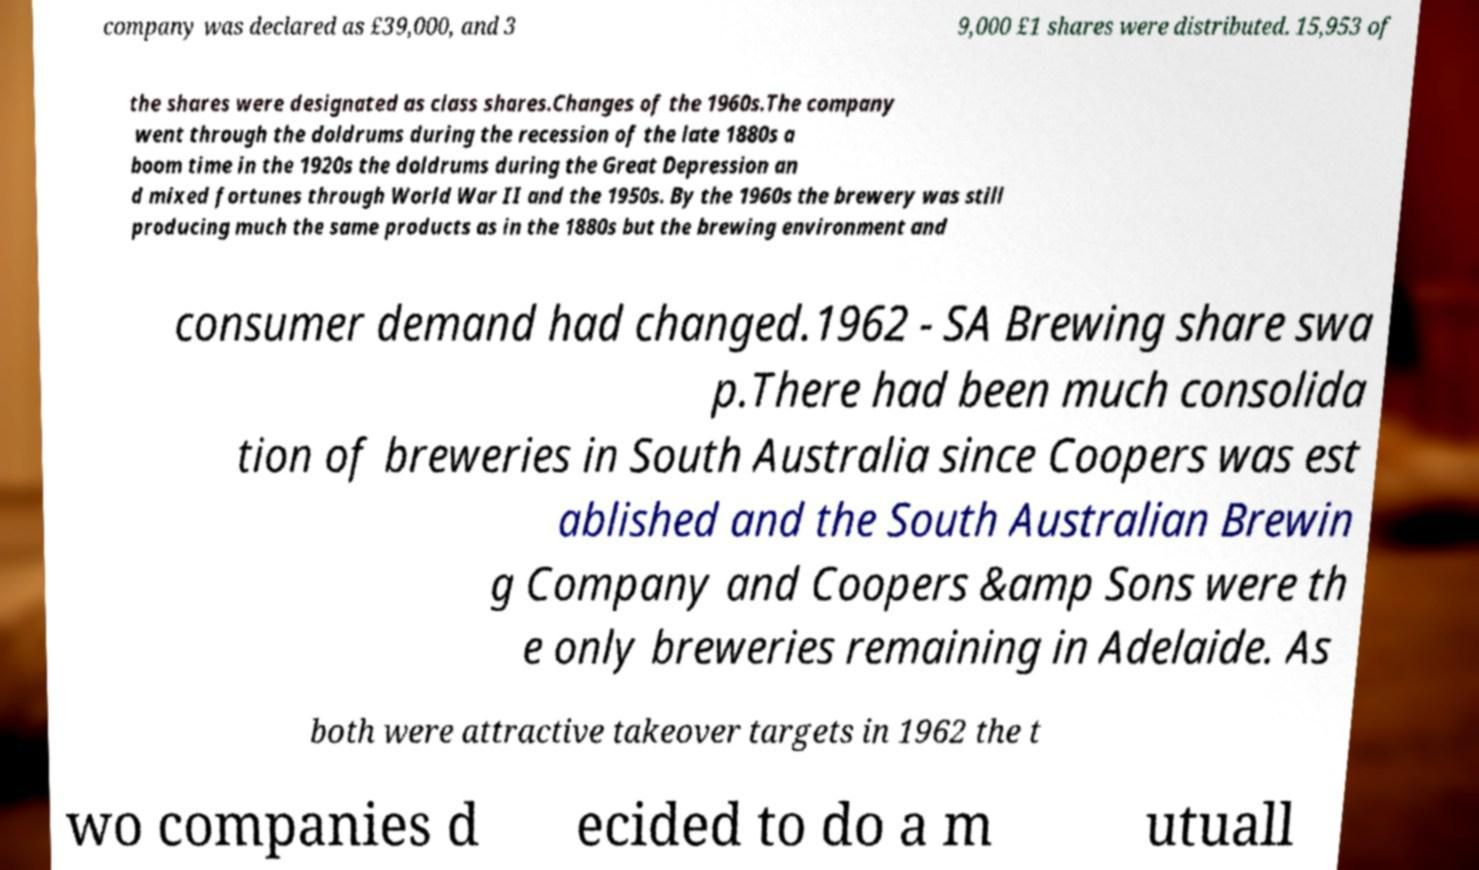I need the written content from this picture converted into text. Can you do that? company was declared as £39,000, and 3 9,000 £1 shares were distributed. 15,953 of the shares were designated as class shares.Changes of the 1960s.The company went through the doldrums during the recession of the late 1880s a boom time in the 1920s the doldrums during the Great Depression an d mixed fortunes through World War II and the 1950s. By the 1960s the brewery was still producing much the same products as in the 1880s but the brewing environment and consumer demand had changed.1962 - SA Brewing share swa p.There had been much consolida tion of breweries in South Australia since Coopers was est ablished and the South Australian Brewin g Company and Coopers &amp Sons were th e only breweries remaining in Adelaide. As both were attractive takeover targets in 1962 the t wo companies d ecided to do a m utuall 